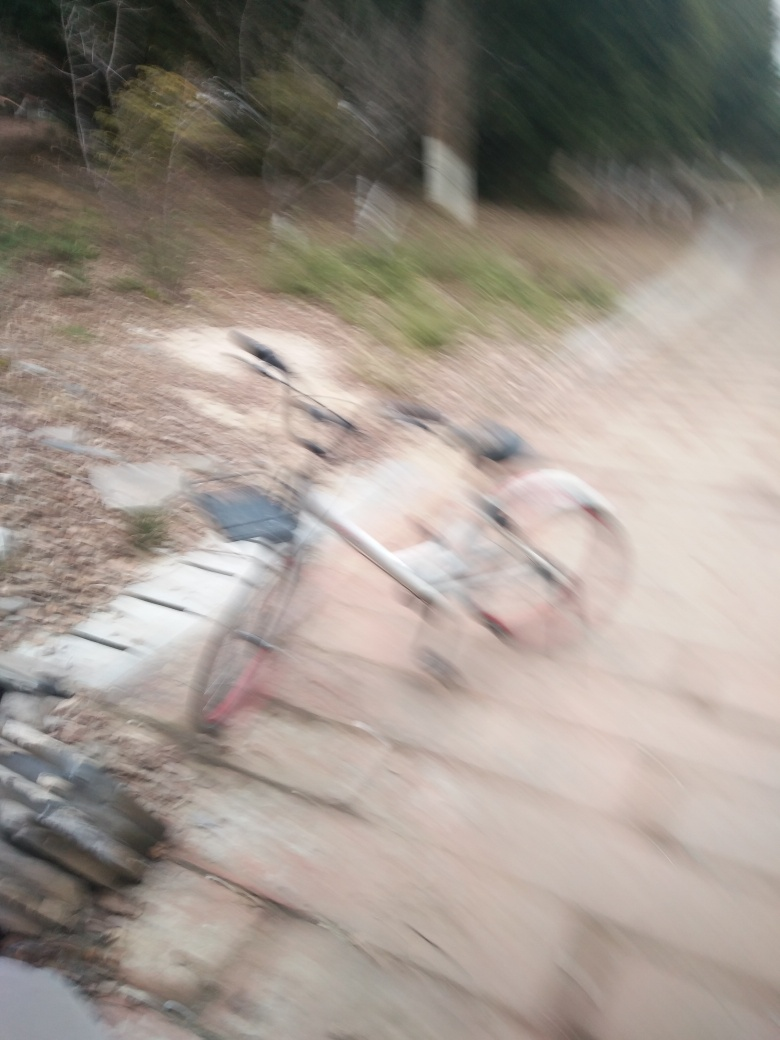Can you tell me what time of day this photo might have been taken? Though the photo's clarity is compromised, the lighting conditions suggest it could be in the late afternoon or early evening, based on the soft, dim light and the shadows that are cast. The absence of harsh shadows or bright sunlight typically associated with midday is telling. 